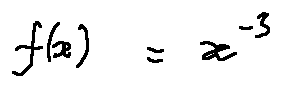Convert formula to latex. <formula><loc_0><loc_0><loc_500><loc_500>f ( x ) = x ^ { - 3 }</formula> 